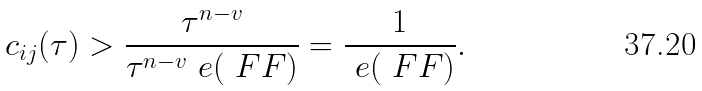Convert formula to latex. <formula><loc_0><loc_0><loc_500><loc_500>c _ { i j } ( \tau ) > \frac { \tau ^ { n - v } } { \tau ^ { n - v } \ e ( \ F F ) } = \frac { 1 } { \ e ( \ F F ) } .</formula> 